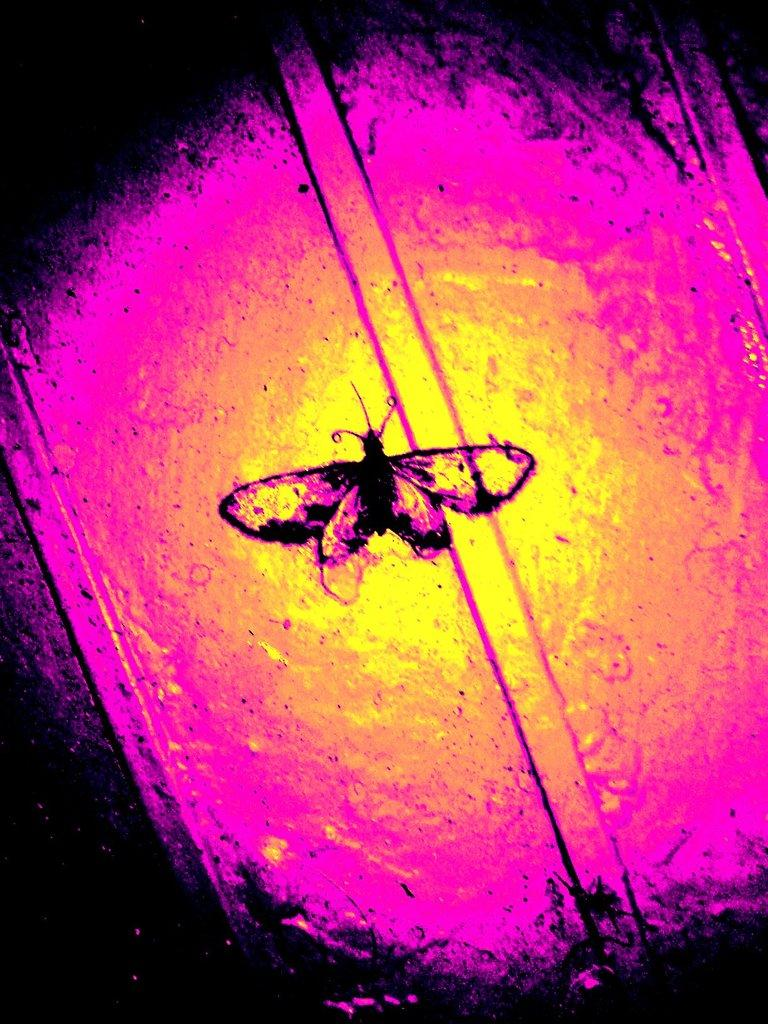What type of creature can be seen in the image? There is an insect in the image. What can be observed about the insect's surroundings? There are multiple colors of surfaces around the insect. How many crackers is the insect eating in the image? There are no crackers present in the image; it features an insect and multiple colored surfaces. How many visitors can be seen interacting with the insect in the image? There are no visitors present in the image; it features an insect and multiple colored surfaces. 